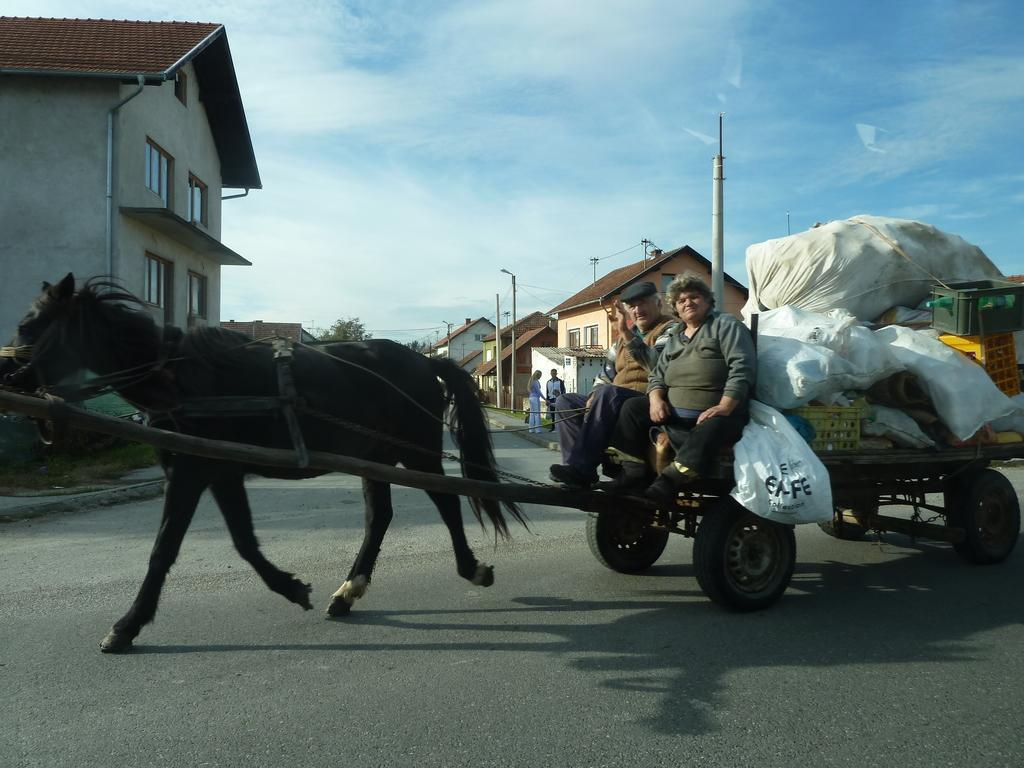Who are the people in the image? There are two old persons, one man and one woman, in the image. What are the old persons carrying with them? The old persons have luggage. What can be seen in the background of the image? There is a horse running and a building in the background of the image. How would you describe the weather in the image? The sky is cloudy in the image. What type of leaf is falling from the tree in the image? There is no tree or leaf present in the image. Is the horse wearing a winter coat in the image? There is no horse wearing a coat in the image; it is simply running in the background. 